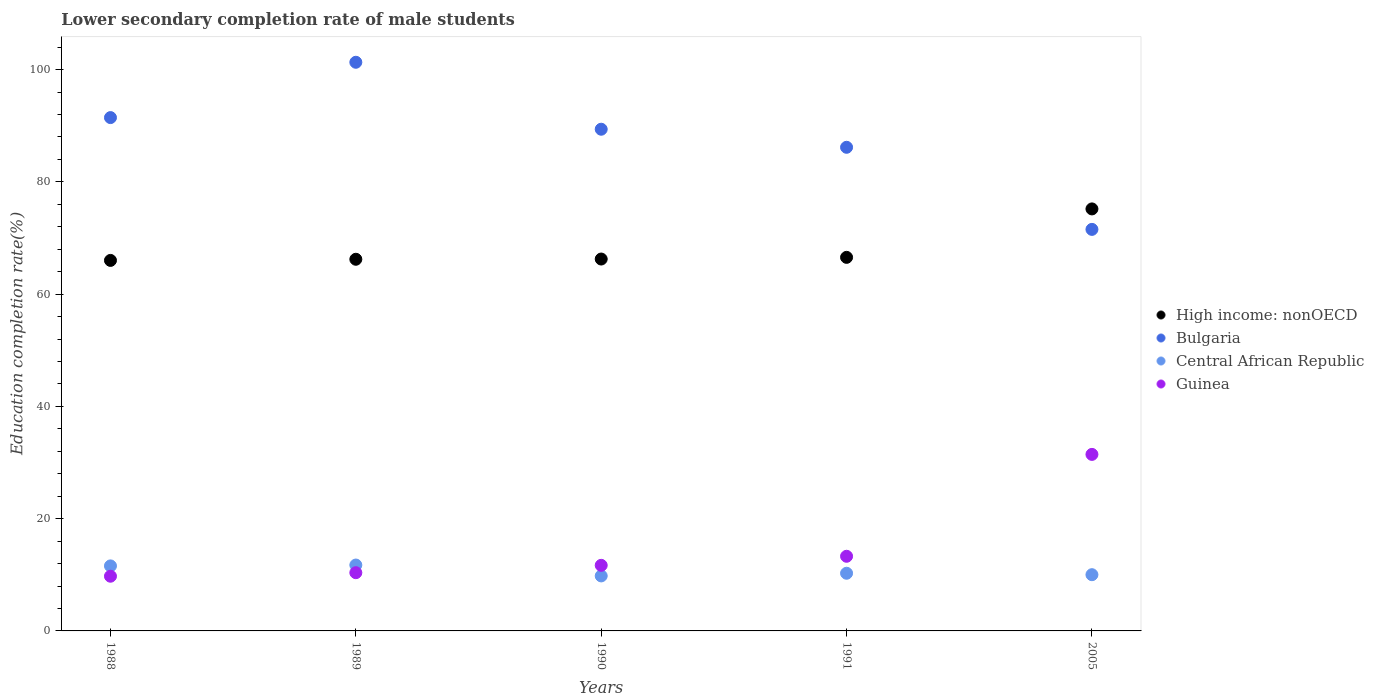How many different coloured dotlines are there?
Your response must be concise. 4. What is the lower secondary completion rate of male students in High income: nonOECD in 2005?
Your answer should be very brief. 75.18. Across all years, what is the maximum lower secondary completion rate of male students in High income: nonOECD?
Keep it short and to the point. 75.18. Across all years, what is the minimum lower secondary completion rate of male students in Central African Republic?
Keep it short and to the point. 9.8. What is the total lower secondary completion rate of male students in High income: nonOECD in the graph?
Ensure brevity in your answer.  340.21. What is the difference between the lower secondary completion rate of male students in Central African Republic in 1988 and that in 1991?
Provide a succinct answer. 1.31. What is the difference between the lower secondary completion rate of male students in Guinea in 1990 and the lower secondary completion rate of male students in High income: nonOECD in 2005?
Your answer should be very brief. -63.5. What is the average lower secondary completion rate of male students in Guinea per year?
Offer a terse response. 15.31. In the year 1991, what is the difference between the lower secondary completion rate of male students in Bulgaria and lower secondary completion rate of male students in High income: nonOECD?
Your answer should be compact. 19.61. What is the ratio of the lower secondary completion rate of male students in Central African Republic in 1988 to that in 1990?
Your answer should be very brief. 1.18. Is the lower secondary completion rate of male students in Guinea in 1988 less than that in 1991?
Give a very brief answer. Yes. Is the difference between the lower secondary completion rate of male students in Bulgaria in 1988 and 1989 greater than the difference between the lower secondary completion rate of male students in High income: nonOECD in 1988 and 1989?
Offer a terse response. No. What is the difference between the highest and the second highest lower secondary completion rate of male students in Bulgaria?
Provide a succinct answer. 9.86. What is the difference between the highest and the lowest lower secondary completion rate of male students in Guinea?
Keep it short and to the point. 21.7. Does the lower secondary completion rate of male students in High income: nonOECD monotonically increase over the years?
Offer a terse response. Yes. Is the lower secondary completion rate of male students in High income: nonOECD strictly less than the lower secondary completion rate of male students in Guinea over the years?
Offer a very short reply. No. How many dotlines are there?
Provide a succinct answer. 4. How many years are there in the graph?
Provide a succinct answer. 5. Are the values on the major ticks of Y-axis written in scientific E-notation?
Make the answer very short. No. Does the graph contain grids?
Give a very brief answer. No. How are the legend labels stacked?
Offer a very short reply. Vertical. What is the title of the graph?
Provide a succinct answer. Lower secondary completion rate of male students. Does "Burkina Faso" appear as one of the legend labels in the graph?
Make the answer very short. No. What is the label or title of the Y-axis?
Ensure brevity in your answer.  Education completion rate(%). What is the Education completion rate(%) in High income: nonOECD in 1988?
Make the answer very short. 66.01. What is the Education completion rate(%) in Bulgaria in 1988?
Your answer should be very brief. 91.45. What is the Education completion rate(%) in Central African Republic in 1988?
Provide a short and direct response. 11.58. What is the Education completion rate(%) in Guinea in 1988?
Your answer should be very brief. 9.75. What is the Education completion rate(%) of High income: nonOECD in 1989?
Your answer should be very brief. 66.21. What is the Education completion rate(%) in Bulgaria in 1989?
Keep it short and to the point. 101.31. What is the Education completion rate(%) in Central African Republic in 1989?
Your answer should be very brief. 11.74. What is the Education completion rate(%) of Guinea in 1989?
Ensure brevity in your answer.  10.37. What is the Education completion rate(%) in High income: nonOECD in 1990?
Give a very brief answer. 66.25. What is the Education completion rate(%) of Bulgaria in 1990?
Offer a very short reply. 89.38. What is the Education completion rate(%) in Central African Republic in 1990?
Make the answer very short. 9.8. What is the Education completion rate(%) of Guinea in 1990?
Give a very brief answer. 11.68. What is the Education completion rate(%) in High income: nonOECD in 1991?
Keep it short and to the point. 66.55. What is the Education completion rate(%) in Bulgaria in 1991?
Provide a succinct answer. 86.16. What is the Education completion rate(%) in Central African Republic in 1991?
Make the answer very short. 10.27. What is the Education completion rate(%) in Guinea in 1991?
Keep it short and to the point. 13.3. What is the Education completion rate(%) in High income: nonOECD in 2005?
Ensure brevity in your answer.  75.18. What is the Education completion rate(%) in Bulgaria in 2005?
Your answer should be compact. 71.54. What is the Education completion rate(%) of Central African Republic in 2005?
Your response must be concise. 10.02. What is the Education completion rate(%) of Guinea in 2005?
Your answer should be compact. 31.45. Across all years, what is the maximum Education completion rate(%) of High income: nonOECD?
Provide a succinct answer. 75.18. Across all years, what is the maximum Education completion rate(%) in Bulgaria?
Provide a succinct answer. 101.31. Across all years, what is the maximum Education completion rate(%) of Central African Republic?
Make the answer very short. 11.74. Across all years, what is the maximum Education completion rate(%) in Guinea?
Offer a terse response. 31.45. Across all years, what is the minimum Education completion rate(%) in High income: nonOECD?
Your answer should be compact. 66.01. Across all years, what is the minimum Education completion rate(%) of Bulgaria?
Offer a terse response. 71.54. Across all years, what is the minimum Education completion rate(%) in Central African Republic?
Ensure brevity in your answer.  9.8. Across all years, what is the minimum Education completion rate(%) in Guinea?
Offer a very short reply. 9.75. What is the total Education completion rate(%) of High income: nonOECD in the graph?
Your answer should be very brief. 340.21. What is the total Education completion rate(%) of Bulgaria in the graph?
Your answer should be very brief. 439.84. What is the total Education completion rate(%) in Central African Republic in the graph?
Your response must be concise. 53.41. What is the total Education completion rate(%) in Guinea in the graph?
Ensure brevity in your answer.  76.55. What is the difference between the Education completion rate(%) in High income: nonOECD in 1988 and that in 1989?
Give a very brief answer. -0.2. What is the difference between the Education completion rate(%) in Bulgaria in 1988 and that in 1989?
Your answer should be compact. -9.86. What is the difference between the Education completion rate(%) in Central African Republic in 1988 and that in 1989?
Provide a short and direct response. -0.15. What is the difference between the Education completion rate(%) of Guinea in 1988 and that in 1989?
Provide a short and direct response. -0.63. What is the difference between the Education completion rate(%) of High income: nonOECD in 1988 and that in 1990?
Keep it short and to the point. -0.25. What is the difference between the Education completion rate(%) in Bulgaria in 1988 and that in 1990?
Keep it short and to the point. 2.07. What is the difference between the Education completion rate(%) in Central African Republic in 1988 and that in 1990?
Offer a very short reply. 1.78. What is the difference between the Education completion rate(%) in Guinea in 1988 and that in 1990?
Provide a short and direct response. -1.94. What is the difference between the Education completion rate(%) of High income: nonOECD in 1988 and that in 1991?
Offer a terse response. -0.54. What is the difference between the Education completion rate(%) in Bulgaria in 1988 and that in 1991?
Provide a succinct answer. 5.29. What is the difference between the Education completion rate(%) of Central African Republic in 1988 and that in 1991?
Offer a very short reply. 1.31. What is the difference between the Education completion rate(%) in Guinea in 1988 and that in 1991?
Offer a terse response. -3.55. What is the difference between the Education completion rate(%) in High income: nonOECD in 1988 and that in 2005?
Your answer should be very brief. -9.17. What is the difference between the Education completion rate(%) of Bulgaria in 1988 and that in 2005?
Provide a short and direct response. 19.92. What is the difference between the Education completion rate(%) in Central African Republic in 1988 and that in 2005?
Offer a terse response. 1.57. What is the difference between the Education completion rate(%) in Guinea in 1988 and that in 2005?
Keep it short and to the point. -21.7. What is the difference between the Education completion rate(%) of High income: nonOECD in 1989 and that in 1990?
Give a very brief answer. -0.04. What is the difference between the Education completion rate(%) in Bulgaria in 1989 and that in 1990?
Ensure brevity in your answer.  11.93. What is the difference between the Education completion rate(%) of Central African Republic in 1989 and that in 1990?
Your answer should be very brief. 1.94. What is the difference between the Education completion rate(%) in Guinea in 1989 and that in 1990?
Your answer should be compact. -1.31. What is the difference between the Education completion rate(%) of High income: nonOECD in 1989 and that in 1991?
Keep it short and to the point. -0.34. What is the difference between the Education completion rate(%) of Bulgaria in 1989 and that in 1991?
Your answer should be very brief. 15.15. What is the difference between the Education completion rate(%) in Central African Republic in 1989 and that in 1991?
Give a very brief answer. 1.46. What is the difference between the Education completion rate(%) of Guinea in 1989 and that in 1991?
Provide a succinct answer. -2.92. What is the difference between the Education completion rate(%) of High income: nonOECD in 1989 and that in 2005?
Your answer should be compact. -8.97. What is the difference between the Education completion rate(%) of Bulgaria in 1989 and that in 2005?
Give a very brief answer. 29.77. What is the difference between the Education completion rate(%) of Central African Republic in 1989 and that in 2005?
Offer a terse response. 1.72. What is the difference between the Education completion rate(%) in Guinea in 1989 and that in 2005?
Provide a succinct answer. -21.07. What is the difference between the Education completion rate(%) of High income: nonOECD in 1990 and that in 1991?
Offer a very short reply. -0.3. What is the difference between the Education completion rate(%) in Bulgaria in 1990 and that in 1991?
Your response must be concise. 3.22. What is the difference between the Education completion rate(%) of Central African Republic in 1990 and that in 1991?
Keep it short and to the point. -0.47. What is the difference between the Education completion rate(%) of Guinea in 1990 and that in 1991?
Offer a terse response. -1.62. What is the difference between the Education completion rate(%) of High income: nonOECD in 1990 and that in 2005?
Offer a terse response. -8.93. What is the difference between the Education completion rate(%) in Bulgaria in 1990 and that in 2005?
Provide a short and direct response. 17.84. What is the difference between the Education completion rate(%) of Central African Republic in 1990 and that in 2005?
Your answer should be very brief. -0.22. What is the difference between the Education completion rate(%) in Guinea in 1990 and that in 2005?
Keep it short and to the point. -19.77. What is the difference between the Education completion rate(%) of High income: nonOECD in 1991 and that in 2005?
Your response must be concise. -8.63. What is the difference between the Education completion rate(%) in Bulgaria in 1991 and that in 2005?
Your response must be concise. 14.63. What is the difference between the Education completion rate(%) of Central African Republic in 1991 and that in 2005?
Your answer should be very brief. 0.26. What is the difference between the Education completion rate(%) in Guinea in 1991 and that in 2005?
Your response must be concise. -18.15. What is the difference between the Education completion rate(%) of High income: nonOECD in 1988 and the Education completion rate(%) of Bulgaria in 1989?
Ensure brevity in your answer.  -35.3. What is the difference between the Education completion rate(%) of High income: nonOECD in 1988 and the Education completion rate(%) of Central African Republic in 1989?
Provide a short and direct response. 54.27. What is the difference between the Education completion rate(%) of High income: nonOECD in 1988 and the Education completion rate(%) of Guinea in 1989?
Ensure brevity in your answer.  55.63. What is the difference between the Education completion rate(%) in Bulgaria in 1988 and the Education completion rate(%) in Central African Republic in 1989?
Give a very brief answer. 79.71. What is the difference between the Education completion rate(%) in Bulgaria in 1988 and the Education completion rate(%) in Guinea in 1989?
Give a very brief answer. 81.08. What is the difference between the Education completion rate(%) of Central African Republic in 1988 and the Education completion rate(%) of Guinea in 1989?
Ensure brevity in your answer.  1.21. What is the difference between the Education completion rate(%) in High income: nonOECD in 1988 and the Education completion rate(%) in Bulgaria in 1990?
Your answer should be very brief. -23.37. What is the difference between the Education completion rate(%) of High income: nonOECD in 1988 and the Education completion rate(%) of Central African Republic in 1990?
Offer a very short reply. 56.21. What is the difference between the Education completion rate(%) in High income: nonOECD in 1988 and the Education completion rate(%) in Guinea in 1990?
Make the answer very short. 54.33. What is the difference between the Education completion rate(%) of Bulgaria in 1988 and the Education completion rate(%) of Central African Republic in 1990?
Ensure brevity in your answer.  81.65. What is the difference between the Education completion rate(%) in Bulgaria in 1988 and the Education completion rate(%) in Guinea in 1990?
Offer a very short reply. 79.77. What is the difference between the Education completion rate(%) of Central African Republic in 1988 and the Education completion rate(%) of Guinea in 1990?
Ensure brevity in your answer.  -0.1. What is the difference between the Education completion rate(%) of High income: nonOECD in 1988 and the Education completion rate(%) of Bulgaria in 1991?
Offer a very short reply. -20.15. What is the difference between the Education completion rate(%) in High income: nonOECD in 1988 and the Education completion rate(%) in Central African Republic in 1991?
Your response must be concise. 55.73. What is the difference between the Education completion rate(%) in High income: nonOECD in 1988 and the Education completion rate(%) in Guinea in 1991?
Provide a succinct answer. 52.71. What is the difference between the Education completion rate(%) of Bulgaria in 1988 and the Education completion rate(%) of Central African Republic in 1991?
Ensure brevity in your answer.  81.18. What is the difference between the Education completion rate(%) in Bulgaria in 1988 and the Education completion rate(%) in Guinea in 1991?
Offer a terse response. 78.15. What is the difference between the Education completion rate(%) of Central African Republic in 1988 and the Education completion rate(%) of Guinea in 1991?
Ensure brevity in your answer.  -1.72. What is the difference between the Education completion rate(%) of High income: nonOECD in 1988 and the Education completion rate(%) of Bulgaria in 2005?
Your response must be concise. -5.53. What is the difference between the Education completion rate(%) in High income: nonOECD in 1988 and the Education completion rate(%) in Central African Republic in 2005?
Give a very brief answer. 55.99. What is the difference between the Education completion rate(%) of High income: nonOECD in 1988 and the Education completion rate(%) of Guinea in 2005?
Make the answer very short. 34.56. What is the difference between the Education completion rate(%) of Bulgaria in 1988 and the Education completion rate(%) of Central African Republic in 2005?
Keep it short and to the point. 81.43. What is the difference between the Education completion rate(%) in Bulgaria in 1988 and the Education completion rate(%) in Guinea in 2005?
Your answer should be compact. 60. What is the difference between the Education completion rate(%) of Central African Republic in 1988 and the Education completion rate(%) of Guinea in 2005?
Give a very brief answer. -19.87. What is the difference between the Education completion rate(%) of High income: nonOECD in 1989 and the Education completion rate(%) of Bulgaria in 1990?
Make the answer very short. -23.17. What is the difference between the Education completion rate(%) in High income: nonOECD in 1989 and the Education completion rate(%) in Central African Republic in 1990?
Your response must be concise. 56.41. What is the difference between the Education completion rate(%) of High income: nonOECD in 1989 and the Education completion rate(%) of Guinea in 1990?
Your response must be concise. 54.53. What is the difference between the Education completion rate(%) of Bulgaria in 1989 and the Education completion rate(%) of Central African Republic in 1990?
Offer a very short reply. 91.51. What is the difference between the Education completion rate(%) of Bulgaria in 1989 and the Education completion rate(%) of Guinea in 1990?
Provide a succinct answer. 89.62. What is the difference between the Education completion rate(%) in Central African Republic in 1989 and the Education completion rate(%) in Guinea in 1990?
Provide a short and direct response. 0.05. What is the difference between the Education completion rate(%) of High income: nonOECD in 1989 and the Education completion rate(%) of Bulgaria in 1991?
Your response must be concise. -19.95. What is the difference between the Education completion rate(%) in High income: nonOECD in 1989 and the Education completion rate(%) in Central African Republic in 1991?
Ensure brevity in your answer.  55.94. What is the difference between the Education completion rate(%) of High income: nonOECD in 1989 and the Education completion rate(%) of Guinea in 1991?
Offer a terse response. 52.91. What is the difference between the Education completion rate(%) in Bulgaria in 1989 and the Education completion rate(%) in Central African Republic in 1991?
Your response must be concise. 91.03. What is the difference between the Education completion rate(%) of Bulgaria in 1989 and the Education completion rate(%) of Guinea in 1991?
Give a very brief answer. 88.01. What is the difference between the Education completion rate(%) of Central African Republic in 1989 and the Education completion rate(%) of Guinea in 1991?
Your answer should be very brief. -1.56. What is the difference between the Education completion rate(%) in High income: nonOECD in 1989 and the Education completion rate(%) in Bulgaria in 2005?
Your response must be concise. -5.32. What is the difference between the Education completion rate(%) in High income: nonOECD in 1989 and the Education completion rate(%) in Central African Republic in 2005?
Your answer should be compact. 56.19. What is the difference between the Education completion rate(%) in High income: nonOECD in 1989 and the Education completion rate(%) in Guinea in 2005?
Offer a very short reply. 34.76. What is the difference between the Education completion rate(%) in Bulgaria in 1989 and the Education completion rate(%) in Central African Republic in 2005?
Your answer should be very brief. 91.29. What is the difference between the Education completion rate(%) in Bulgaria in 1989 and the Education completion rate(%) in Guinea in 2005?
Offer a terse response. 69.86. What is the difference between the Education completion rate(%) in Central African Republic in 1989 and the Education completion rate(%) in Guinea in 2005?
Keep it short and to the point. -19.71. What is the difference between the Education completion rate(%) in High income: nonOECD in 1990 and the Education completion rate(%) in Bulgaria in 1991?
Keep it short and to the point. -19.91. What is the difference between the Education completion rate(%) of High income: nonOECD in 1990 and the Education completion rate(%) of Central African Republic in 1991?
Your answer should be very brief. 55.98. What is the difference between the Education completion rate(%) in High income: nonOECD in 1990 and the Education completion rate(%) in Guinea in 1991?
Provide a succinct answer. 52.95. What is the difference between the Education completion rate(%) in Bulgaria in 1990 and the Education completion rate(%) in Central African Republic in 1991?
Offer a terse response. 79.1. What is the difference between the Education completion rate(%) in Bulgaria in 1990 and the Education completion rate(%) in Guinea in 1991?
Offer a terse response. 76.08. What is the difference between the Education completion rate(%) in Central African Republic in 1990 and the Education completion rate(%) in Guinea in 1991?
Provide a succinct answer. -3.5. What is the difference between the Education completion rate(%) in High income: nonOECD in 1990 and the Education completion rate(%) in Bulgaria in 2005?
Give a very brief answer. -5.28. What is the difference between the Education completion rate(%) in High income: nonOECD in 1990 and the Education completion rate(%) in Central African Republic in 2005?
Make the answer very short. 56.24. What is the difference between the Education completion rate(%) of High income: nonOECD in 1990 and the Education completion rate(%) of Guinea in 2005?
Offer a very short reply. 34.81. What is the difference between the Education completion rate(%) of Bulgaria in 1990 and the Education completion rate(%) of Central African Republic in 2005?
Provide a short and direct response. 79.36. What is the difference between the Education completion rate(%) of Bulgaria in 1990 and the Education completion rate(%) of Guinea in 2005?
Provide a short and direct response. 57.93. What is the difference between the Education completion rate(%) of Central African Republic in 1990 and the Education completion rate(%) of Guinea in 2005?
Offer a very short reply. -21.65. What is the difference between the Education completion rate(%) in High income: nonOECD in 1991 and the Education completion rate(%) in Bulgaria in 2005?
Your answer should be compact. -4.98. What is the difference between the Education completion rate(%) of High income: nonOECD in 1991 and the Education completion rate(%) of Central African Republic in 2005?
Provide a succinct answer. 56.54. What is the difference between the Education completion rate(%) of High income: nonOECD in 1991 and the Education completion rate(%) of Guinea in 2005?
Your answer should be very brief. 35.1. What is the difference between the Education completion rate(%) of Bulgaria in 1991 and the Education completion rate(%) of Central African Republic in 2005?
Provide a succinct answer. 76.14. What is the difference between the Education completion rate(%) of Bulgaria in 1991 and the Education completion rate(%) of Guinea in 2005?
Your response must be concise. 54.71. What is the difference between the Education completion rate(%) in Central African Republic in 1991 and the Education completion rate(%) in Guinea in 2005?
Ensure brevity in your answer.  -21.17. What is the average Education completion rate(%) of High income: nonOECD per year?
Your answer should be very brief. 68.04. What is the average Education completion rate(%) in Bulgaria per year?
Ensure brevity in your answer.  87.97. What is the average Education completion rate(%) in Central African Republic per year?
Keep it short and to the point. 10.68. What is the average Education completion rate(%) in Guinea per year?
Your answer should be very brief. 15.31. In the year 1988, what is the difference between the Education completion rate(%) in High income: nonOECD and Education completion rate(%) in Bulgaria?
Offer a terse response. -25.44. In the year 1988, what is the difference between the Education completion rate(%) in High income: nonOECD and Education completion rate(%) in Central African Republic?
Your answer should be very brief. 54.43. In the year 1988, what is the difference between the Education completion rate(%) of High income: nonOECD and Education completion rate(%) of Guinea?
Provide a short and direct response. 56.26. In the year 1988, what is the difference between the Education completion rate(%) in Bulgaria and Education completion rate(%) in Central African Republic?
Make the answer very short. 79.87. In the year 1988, what is the difference between the Education completion rate(%) of Bulgaria and Education completion rate(%) of Guinea?
Provide a short and direct response. 81.71. In the year 1988, what is the difference between the Education completion rate(%) in Central African Republic and Education completion rate(%) in Guinea?
Provide a short and direct response. 1.84. In the year 1989, what is the difference between the Education completion rate(%) of High income: nonOECD and Education completion rate(%) of Bulgaria?
Keep it short and to the point. -35.1. In the year 1989, what is the difference between the Education completion rate(%) in High income: nonOECD and Education completion rate(%) in Central African Republic?
Keep it short and to the point. 54.47. In the year 1989, what is the difference between the Education completion rate(%) in High income: nonOECD and Education completion rate(%) in Guinea?
Your answer should be compact. 55.84. In the year 1989, what is the difference between the Education completion rate(%) in Bulgaria and Education completion rate(%) in Central African Republic?
Keep it short and to the point. 89.57. In the year 1989, what is the difference between the Education completion rate(%) of Bulgaria and Education completion rate(%) of Guinea?
Your answer should be compact. 90.93. In the year 1989, what is the difference between the Education completion rate(%) of Central African Republic and Education completion rate(%) of Guinea?
Offer a terse response. 1.36. In the year 1990, what is the difference between the Education completion rate(%) in High income: nonOECD and Education completion rate(%) in Bulgaria?
Offer a terse response. -23.12. In the year 1990, what is the difference between the Education completion rate(%) of High income: nonOECD and Education completion rate(%) of Central African Republic?
Your answer should be very brief. 56.45. In the year 1990, what is the difference between the Education completion rate(%) in High income: nonOECD and Education completion rate(%) in Guinea?
Make the answer very short. 54.57. In the year 1990, what is the difference between the Education completion rate(%) of Bulgaria and Education completion rate(%) of Central African Republic?
Provide a succinct answer. 79.58. In the year 1990, what is the difference between the Education completion rate(%) of Bulgaria and Education completion rate(%) of Guinea?
Your response must be concise. 77.7. In the year 1990, what is the difference between the Education completion rate(%) in Central African Republic and Education completion rate(%) in Guinea?
Make the answer very short. -1.88. In the year 1991, what is the difference between the Education completion rate(%) in High income: nonOECD and Education completion rate(%) in Bulgaria?
Ensure brevity in your answer.  -19.61. In the year 1991, what is the difference between the Education completion rate(%) in High income: nonOECD and Education completion rate(%) in Central African Republic?
Your response must be concise. 56.28. In the year 1991, what is the difference between the Education completion rate(%) of High income: nonOECD and Education completion rate(%) of Guinea?
Give a very brief answer. 53.25. In the year 1991, what is the difference between the Education completion rate(%) in Bulgaria and Education completion rate(%) in Central African Republic?
Your answer should be compact. 75.89. In the year 1991, what is the difference between the Education completion rate(%) in Bulgaria and Education completion rate(%) in Guinea?
Ensure brevity in your answer.  72.86. In the year 1991, what is the difference between the Education completion rate(%) in Central African Republic and Education completion rate(%) in Guinea?
Offer a very short reply. -3.02. In the year 2005, what is the difference between the Education completion rate(%) of High income: nonOECD and Education completion rate(%) of Bulgaria?
Keep it short and to the point. 3.65. In the year 2005, what is the difference between the Education completion rate(%) of High income: nonOECD and Education completion rate(%) of Central African Republic?
Give a very brief answer. 65.16. In the year 2005, what is the difference between the Education completion rate(%) of High income: nonOECD and Education completion rate(%) of Guinea?
Ensure brevity in your answer.  43.73. In the year 2005, what is the difference between the Education completion rate(%) in Bulgaria and Education completion rate(%) in Central African Republic?
Ensure brevity in your answer.  61.52. In the year 2005, what is the difference between the Education completion rate(%) of Bulgaria and Education completion rate(%) of Guinea?
Provide a succinct answer. 40.09. In the year 2005, what is the difference between the Education completion rate(%) of Central African Republic and Education completion rate(%) of Guinea?
Make the answer very short. -21.43. What is the ratio of the Education completion rate(%) in High income: nonOECD in 1988 to that in 1989?
Offer a terse response. 1. What is the ratio of the Education completion rate(%) in Bulgaria in 1988 to that in 1989?
Provide a short and direct response. 0.9. What is the ratio of the Education completion rate(%) of Central African Republic in 1988 to that in 1989?
Your answer should be compact. 0.99. What is the ratio of the Education completion rate(%) of Guinea in 1988 to that in 1989?
Offer a very short reply. 0.94. What is the ratio of the Education completion rate(%) in Bulgaria in 1988 to that in 1990?
Your answer should be compact. 1.02. What is the ratio of the Education completion rate(%) of Central African Republic in 1988 to that in 1990?
Your answer should be very brief. 1.18. What is the ratio of the Education completion rate(%) in Guinea in 1988 to that in 1990?
Your answer should be very brief. 0.83. What is the ratio of the Education completion rate(%) in High income: nonOECD in 1988 to that in 1991?
Make the answer very short. 0.99. What is the ratio of the Education completion rate(%) in Bulgaria in 1988 to that in 1991?
Provide a succinct answer. 1.06. What is the ratio of the Education completion rate(%) in Central African Republic in 1988 to that in 1991?
Offer a very short reply. 1.13. What is the ratio of the Education completion rate(%) in Guinea in 1988 to that in 1991?
Your answer should be compact. 0.73. What is the ratio of the Education completion rate(%) in High income: nonOECD in 1988 to that in 2005?
Provide a succinct answer. 0.88. What is the ratio of the Education completion rate(%) of Bulgaria in 1988 to that in 2005?
Provide a short and direct response. 1.28. What is the ratio of the Education completion rate(%) in Central African Republic in 1988 to that in 2005?
Your answer should be very brief. 1.16. What is the ratio of the Education completion rate(%) in Guinea in 1988 to that in 2005?
Ensure brevity in your answer.  0.31. What is the ratio of the Education completion rate(%) of High income: nonOECD in 1989 to that in 1990?
Your response must be concise. 1. What is the ratio of the Education completion rate(%) in Bulgaria in 1989 to that in 1990?
Give a very brief answer. 1.13. What is the ratio of the Education completion rate(%) in Central African Republic in 1989 to that in 1990?
Keep it short and to the point. 1.2. What is the ratio of the Education completion rate(%) in Guinea in 1989 to that in 1990?
Provide a succinct answer. 0.89. What is the ratio of the Education completion rate(%) of High income: nonOECD in 1989 to that in 1991?
Provide a succinct answer. 0.99. What is the ratio of the Education completion rate(%) of Bulgaria in 1989 to that in 1991?
Keep it short and to the point. 1.18. What is the ratio of the Education completion rate(%) of Central African Republic in 1989 to that in 1991?
Your answer should be very brief. 1.14. What is the ratio of the Education completion rate(%) in Guinea in 1989 to that in 1991?
Provide a succinct answer. 0.78. What is the ratio of the Education completion rate(%) of High income: nonOECD in 1989 to that in 2005?
Provide a succinct answer. 0.88. What is the ratio of the Education completion rate(%) in Bulgaria in 1989 to that in 2005?
Provide a succinct answer. 1.42. What is the ratio of the Education completion rate(%) in Central African Republic in 1989 to that in 2005?
Provide a succinct answer. 1.17. What is the ratio of the Education completion rate(%) in Guinea in 1989 to that in 2005?
Make the answer very short. 0.33. What is the ratio of the Education completion rate(%) of High income: nonOECD in 1990 to that in 1991?
Ensure brevity in your answer.  1. What is the ratio of the Education completion rate(%) in Bulgaria in 1990 to that in 1991?
Provide a succinct answer. 1.04. What is the ratio of the Education completion rate(%) in Central African Republic in 1990 to that in 1991?
Keep it short and to the point. 0.95. What is the ratio of the Education completion rate(%) of Guinea in 1990 to that in 1991?
Ensure brevity in your answer.  0.88. What is the ratio of the Education completion rate(%) in High income: nonOECD in 1990 to that in 2005?
Offer a terse response. 0.88. What is the ratio of the Education completion rate(%) in Bulgaria in 1990 to that in 2005?
Keep it short and to the point. 1.25. What is the ratio of the Education completion rate(%) of Central African Republic in 1990 to that in 2005?
Your response must be concise. 0.98. What is the ratio of the Education completion rate(%) of Guinea in 1990 to that in 2005?
Give a very brief answer. 0.37. What is the ratio of the Education completion rate(%) in High income: nonOECD in 1991 to that in 2005?
Provide a succinct answer. 0.89. What is the ratio of the Education completion rate(%) in Bulgaria in 1991 to that in 2005?
Ensure brevity in your answer.  1.2. What is the ratio of the Education completion rate(%) in Central African Republic in 1991 to that in 2005?
Your answer should be very brief. 1.03. What is the ratio of the Education completion rate(%) of Guinea in 1991 to that in 2005?
Keep it short and to the point. 0.42. What is the difference between the highest and the second highest Education completion rate(%) in High income: nonOECD?
Give a very brief answer. 8.63. What is the difference between the highest and the second highest Education completion rate(%) of Bulgaria?
Offer a very short reply. 9.86. What is the difference between the highest and the second highest Education completion rate(%) in Central African Republic?
Your answer should be very brief. 0.15. What is the difference between the highest and the second highest Education completion rate(%) in Guinea?
Make the answer very short. 18.15. What is the difference between the highest and the lowest Education completion rate(%) in High income: nonOECD?
Provide a short and direct response. 9.17. What is the difference between the highest and the lowest Education completion rate(%) of Bulgaria?
Your response must be concise. 29.77. What is the difference between the highest and the lowest Education completion rate(%) of Central African Republic?
Your response must be concise. 1.94. What is the difference between the highest and the lowest Education completion rate(%) in Guinea?
Provide a short and direct response. 21.7. 